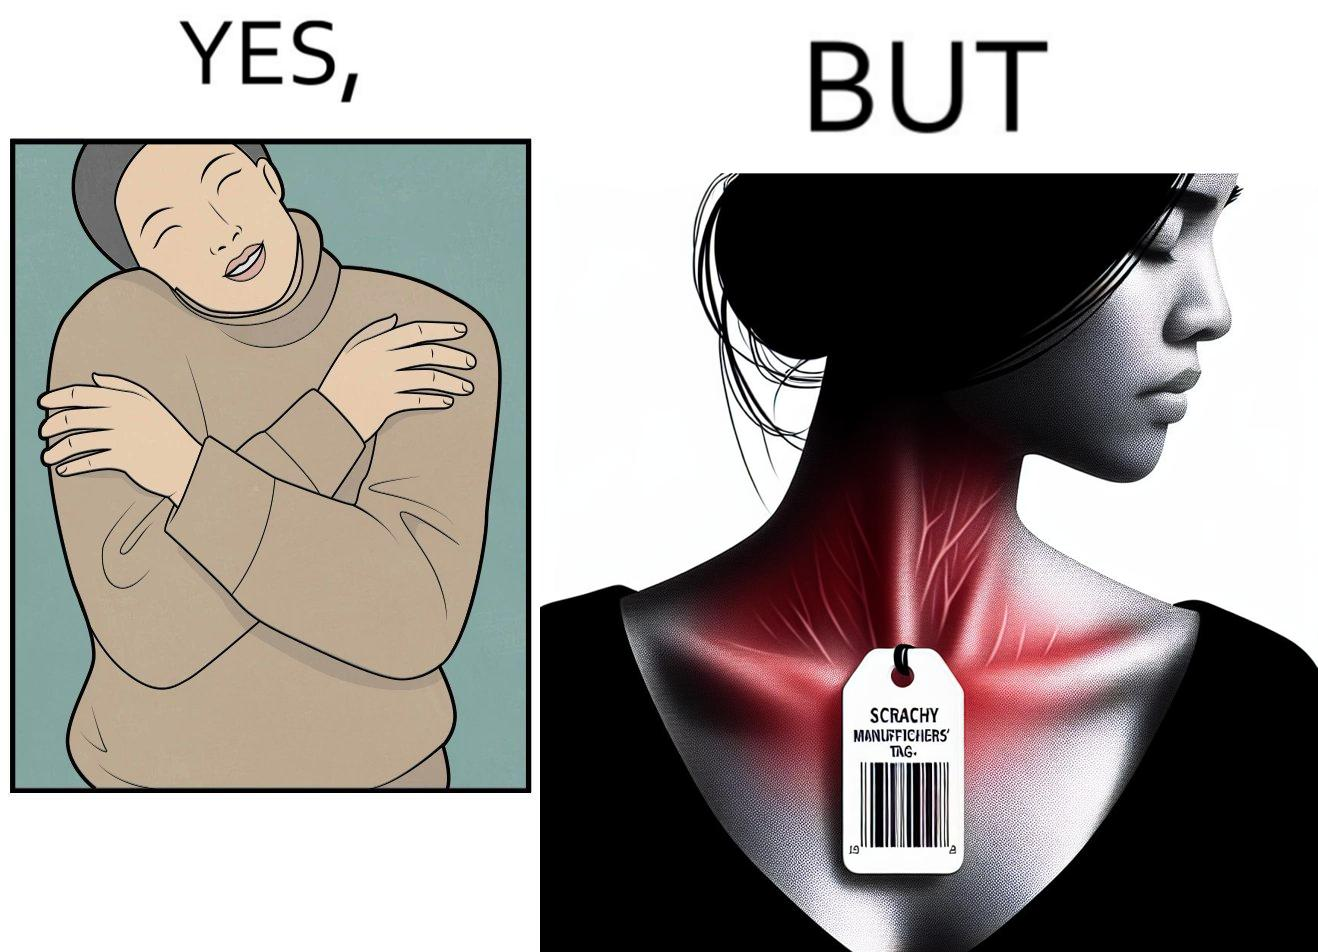Is there satirical content in this image? Yes, this image is satirical. 